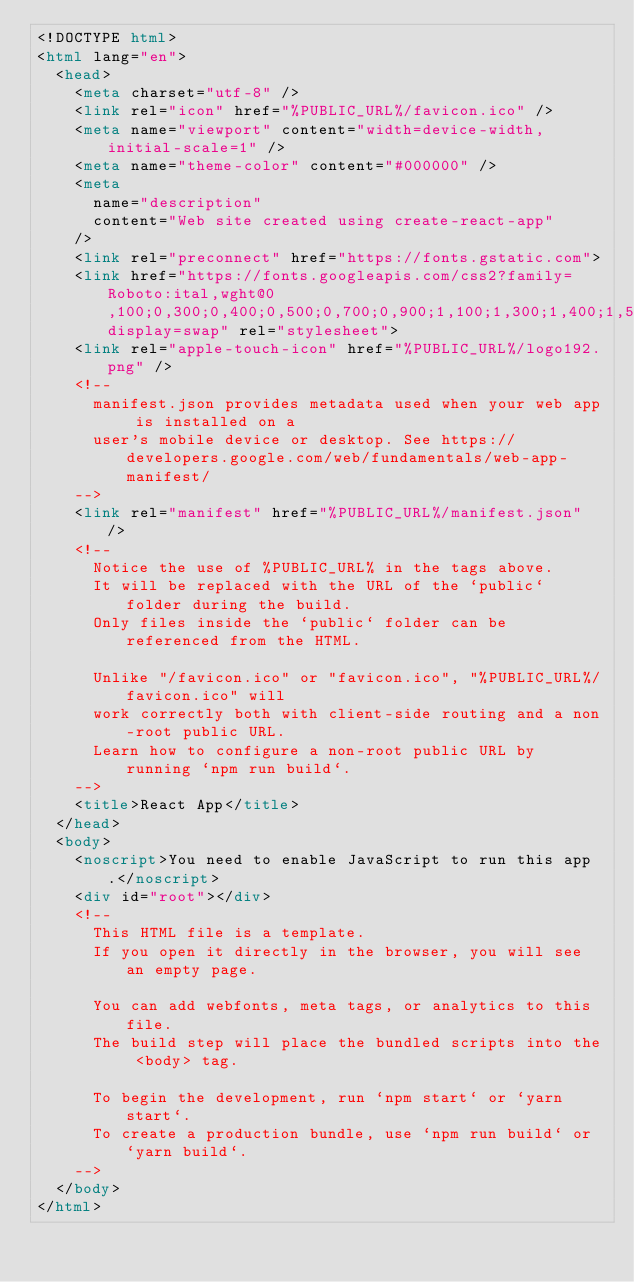<code> <loc_0><loc_0><loc_500><loc_500><_HTML_><!DOCTYPE html>
<html lang="en">
  <head>
    <meta charset="utf-8" />
    <link rel="icon" href="%PUBLIC_URL%/favicon.ico" />
    <meta name="viewport" content="width=device-width, initial-scale=1" />
    <meta name="theme-color" content="#000000" />
    <meta
      name="description"
      content="Web site created using create-react-app"
    />
    <link rel="preconnect" href="https://fonts.gstatic.com">
    <link href="https://fonts.googleapis.com/css2?family=Roboto:ital,wght@0,100;0,300;0,400;0,500;0,700;0,900;1,100;1,300;1,400;1,500;1,700;1,900&display=swap" rel="stylesheet"> 
    <link rel="apple-touch-icon" href="%PUBLIC_URL%/logo192.png" />
    <!--
      manifest.json provides metadata used when your web app is installed on a
      user's mobile device or desktop. See https://developers.google.com/web/fundamentals/web-app-manifest/
    -->
    <link rel="manifest" href="%PUBLIC_URL%/manifest.json" />
    <!--
      Notice the use of %PUBLIC_URL% in the tags above.
      It will be replaced with the URL of the `public` folder during the build.
      Only files inside the `public` folder can be referenced from the HTML.

      Unlike "/favicon.ico" or "favicon.ico", "%PUBLIC_URL%/favicon.ico" will
      work correctly both with client-side routing and a non-root public URL.
      Learn how to configure a non-root public URL by running `npm run build`.
    -->
    <title>React App</title>
  </head>
  <body>
    <noscript>You need to enable JavaScript to run this app.</noscript>
    <div id="root"></div>
    <!--
      This HTML file is a template.
      If you open it directly in the browser, you will see an empty page.

      You can add webfonts, meta tags, or analytics to this file.
      The build step will place the bundled scripts into the <body> tag.

      To begin the development, run `npm start` or `yarn start`.
      To create a production bundle, use `npm run build` or `yarn build`.
    -->
  </body>
</html>
</code> 